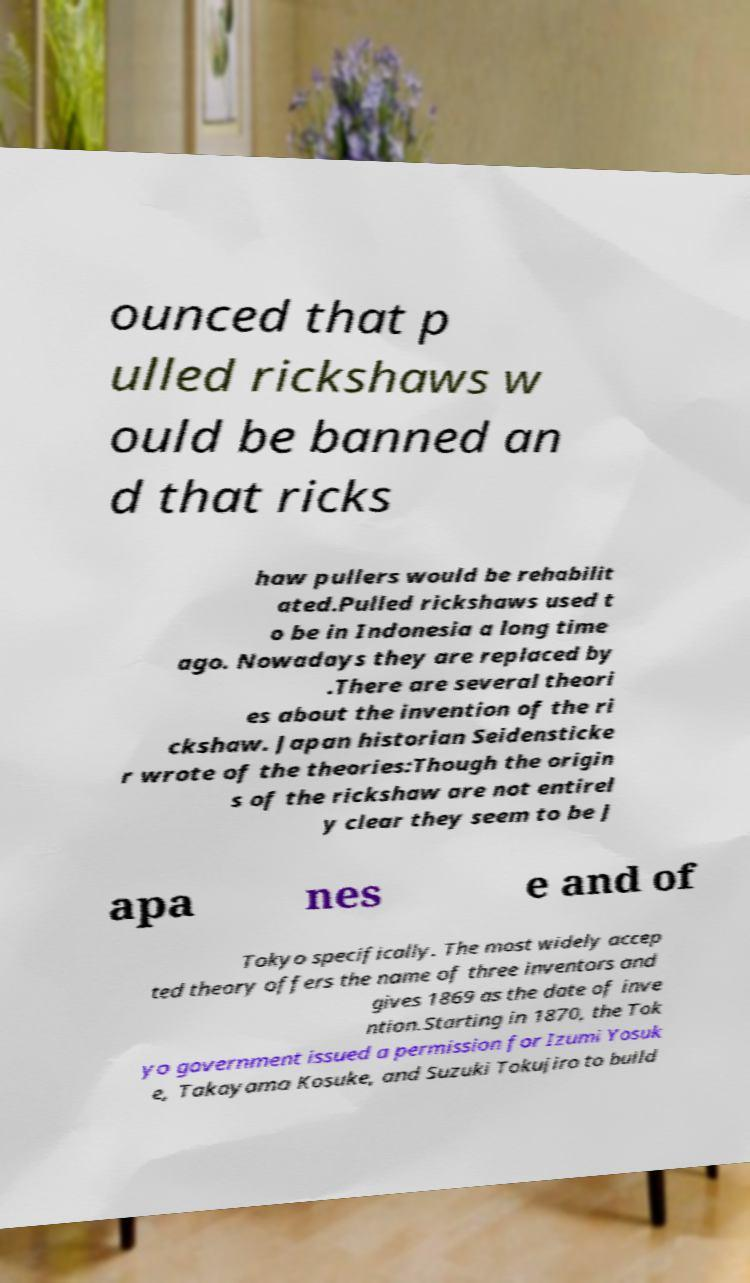Could you extract and type out the text from this image? ounced that p ulled rickshaws w ould be banned an d that ricks haw pullers would be rehabilit ated.Pulled rickshaws used t o be in Indonesia a long time ago. Nowadays they are replaced by .There are several theori es about the invention of the ri ckshaw. Japan historian Seidensticke r wrote of the theories:Though the origin s of the rickshaw are not entirel y clear they seem to be J apa nes e and of Tokyo specifically. The most widely accep ted theory offers the name of three inventors and gives 1869 as the date of inve ntion.Starting in 1870, the Tok yo government issued a permission for Izumi Yosuk e, Takayama Kosuke, and Suzuki Tokujiro to build 